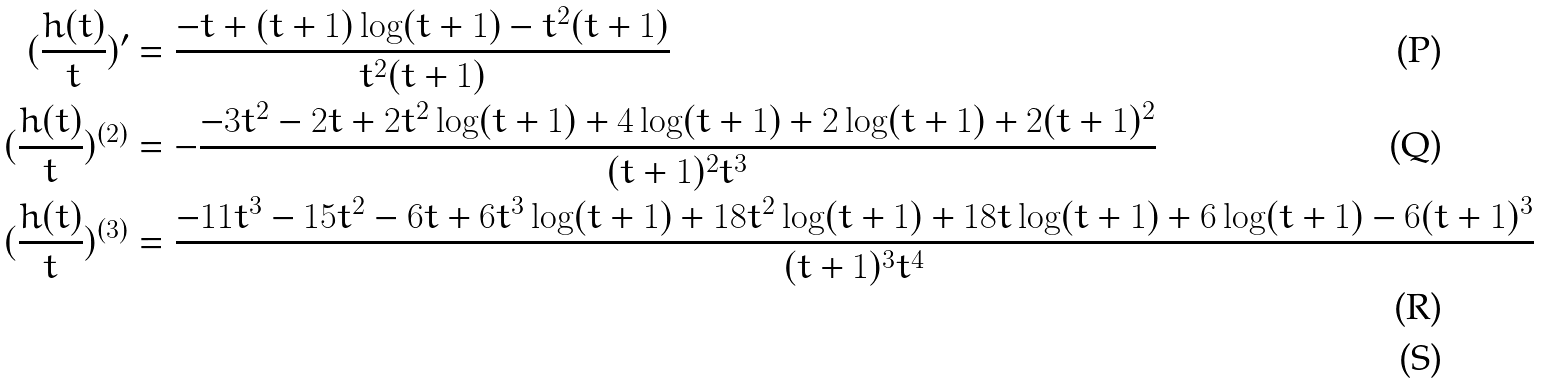<formula> <loc_0><loc_0><loc_500><loc_500>( \frac { h ( t ) } { t } ) ^ { \prime } & = \frac { - t + ( t + 1 ) \log ( t + 1 ) - t ^ { 2 } ( t + 1 ) } { t ^ { 2 } ( t + 1 ) } \\ ( \frac { h ( t ) } { t } ) ^ { ( 2 ) } & = - \frac { - 3 t ^ { 2 } - 2 t + 2 t ^ { 2 } \log ( t + 1 ) + 4 \log ( t + 1 ) + 2 \log ( t + 1 ) + 2 ( t + 1 ) ^ { 2 } } { ( t + 1 ) ^ { 2 } t ^ { 3 } } \\ ( \frac { h ( t ) } { t } ) ^ { ( 3 ) } & = \frac { - 1 1 t ^ { 3 } - 1 5 t ^ { 2 } - 6 t + 6 t ^ { 3 } \log ( t + 1 ) + 1 8 t ^ { 2 } \log ( t + 1 ) + 1 8 t \log ( t + 1 ) + 6 \log ( t + 1 ) - 6 ( t + 1 ) ^ { 3 } } { ( t + 1 ) ^ { 3 } t ^ { 4 } } \\</formula> 